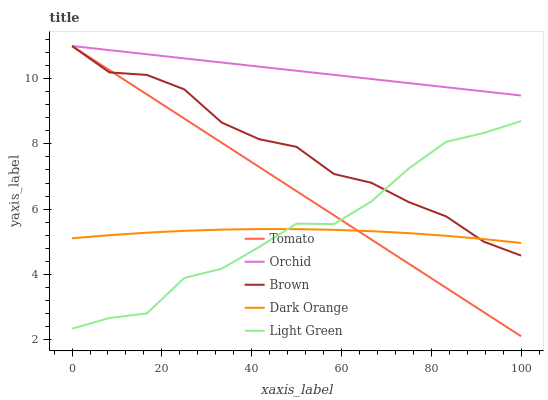Does Dark Orange have the minimum area under the curve?
Answer yes or no. Yes. Does Orchid have the maximum area under the curve?
Answer yes or no. Yes. Does Brown have the minimum area under the curve?
Answer yes or no. No. Does Brown have the maximum area under the curve?
Answer yes or no. No. Is Tomato the smoothest?
Answer yes or no. Yes. Is Light Green the roughest?
Answer yes or no. Yes. Is Brown the smoothest?
Answer yes or no. No. Is Brown the roughest?
Answer yes or no. No. Does Tomato have the lowest value?
Answer yes or no. Yes. Does Brown have the lowest value?
Answer yes or no. No. Does Orchid have the highest value?
Answer yes or no. Yes. Does Light Green have the highest value?
Answer yes or no. No. Is Light Green less than Orchid?
Answer yes or no. Yes. Is Orchid greater than Dark Orange?
Answer yes or no. Yes. Does Dark Orange intersect Brown?
Answer yes or no. Yes. Is Dark Orange less than Brown?
Answer yes or no. No. Is Dark Orange greater than Brown?
Answer yes or no. No. Does Light Green intersect Orchid?
Answer yes or no. No. 